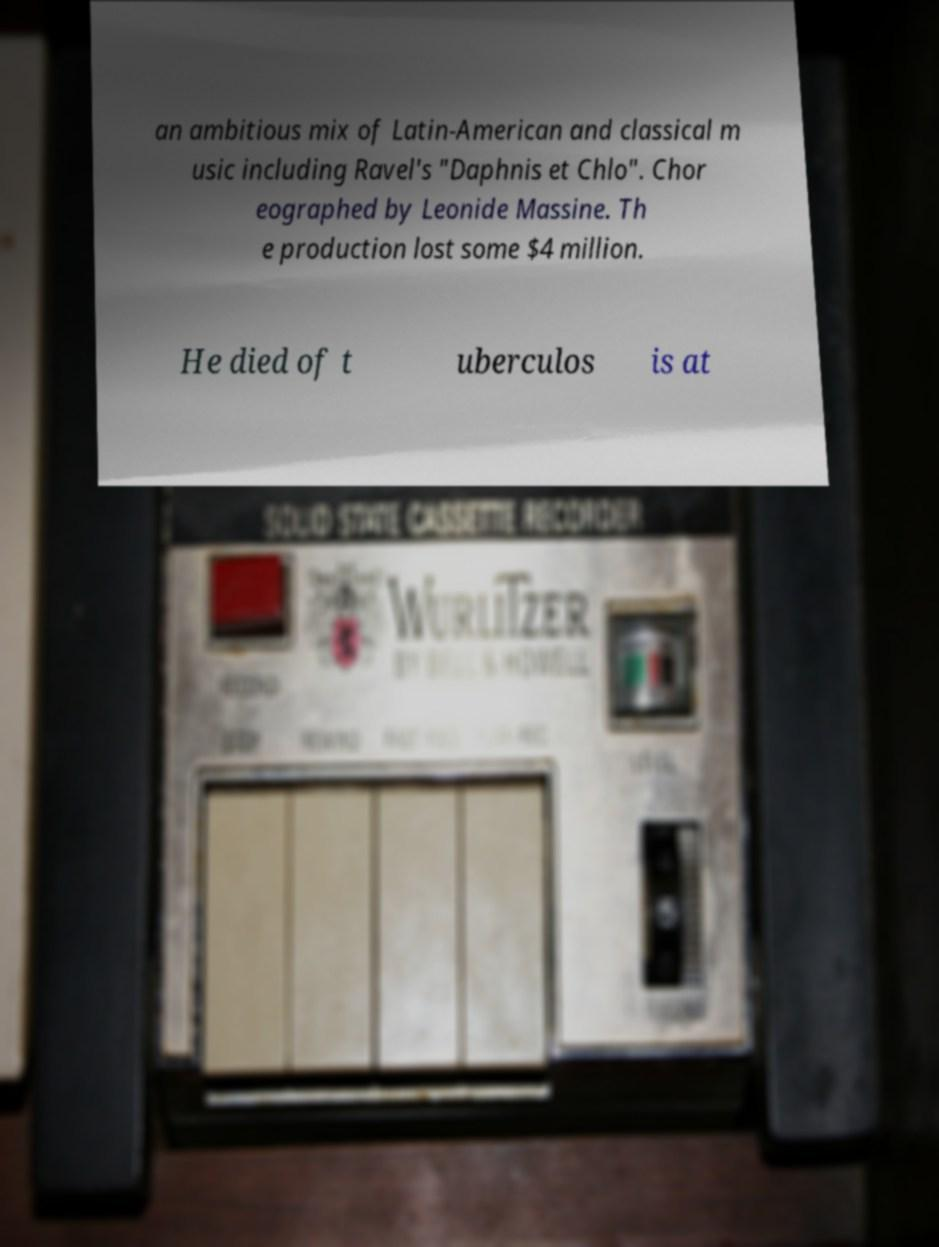Can you read and provide the text displayed in the image?This photo seems to have some interesting text. Can you extract and type it out for me? an ambitious mix of Latin-American and classical m usic including Ravel's "Daphnis et Chlo". Chor eographed by Leonide Massine. Th e production lost some $4 million. He died of t uberculos is at 